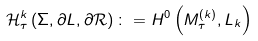<formula> <loc_0><loc_0><loc_500><loc_500>\mathcal { H } _ { \tau } ^ { k } \left ( \Sigma , \partial L , \partial \mathcal { R } \right ) \colon = H ^ { 0 } \left ( M _ { \tau } ^ { \left ( k \right ) } , L _ { k } \right )</formula> 